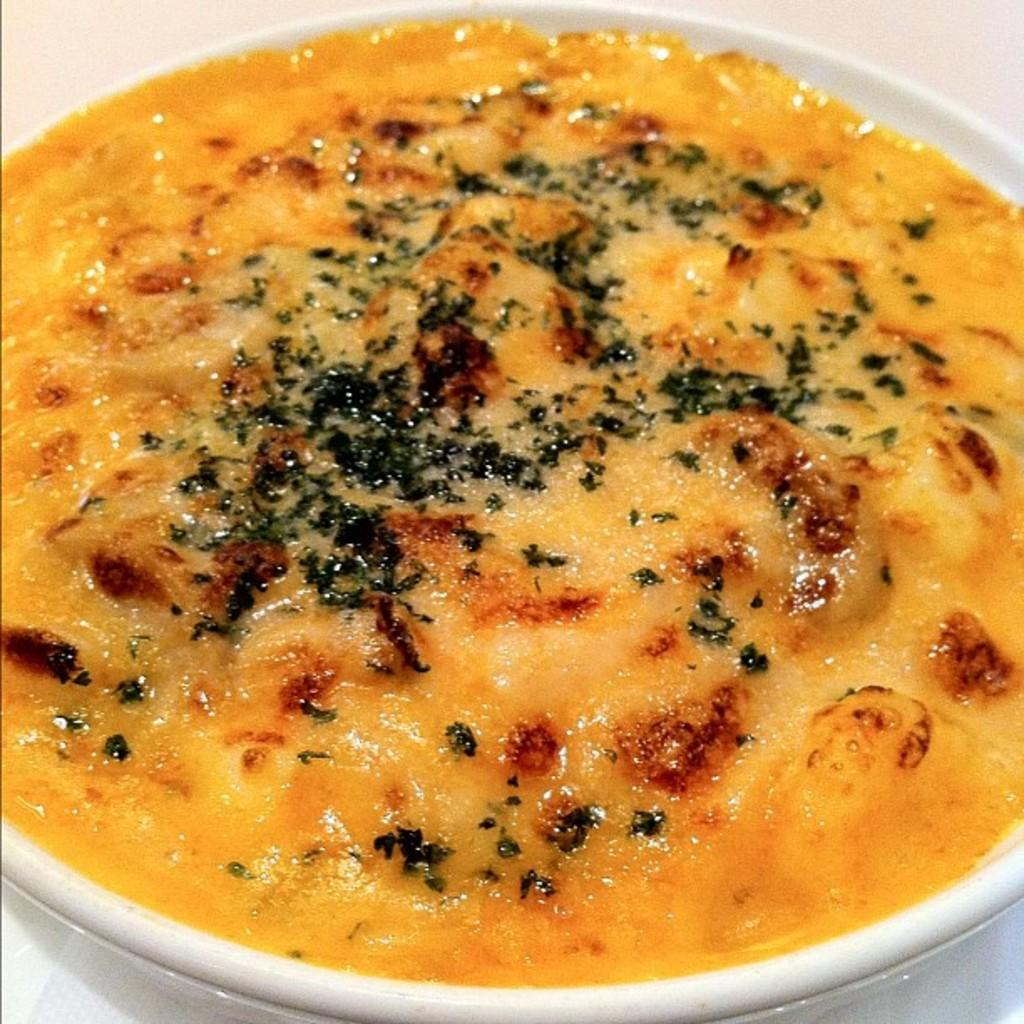What is the main subject in the center of the image? There is an object in the center of the image. What is placed on top of the object? There is a plate on the object. What can be found on the plate? There is a food item on the plate. How many ducks are swimming in the food item on the plate? There are no ducks present in the image, and therefore no ducks can be found in the food item on the plate. 